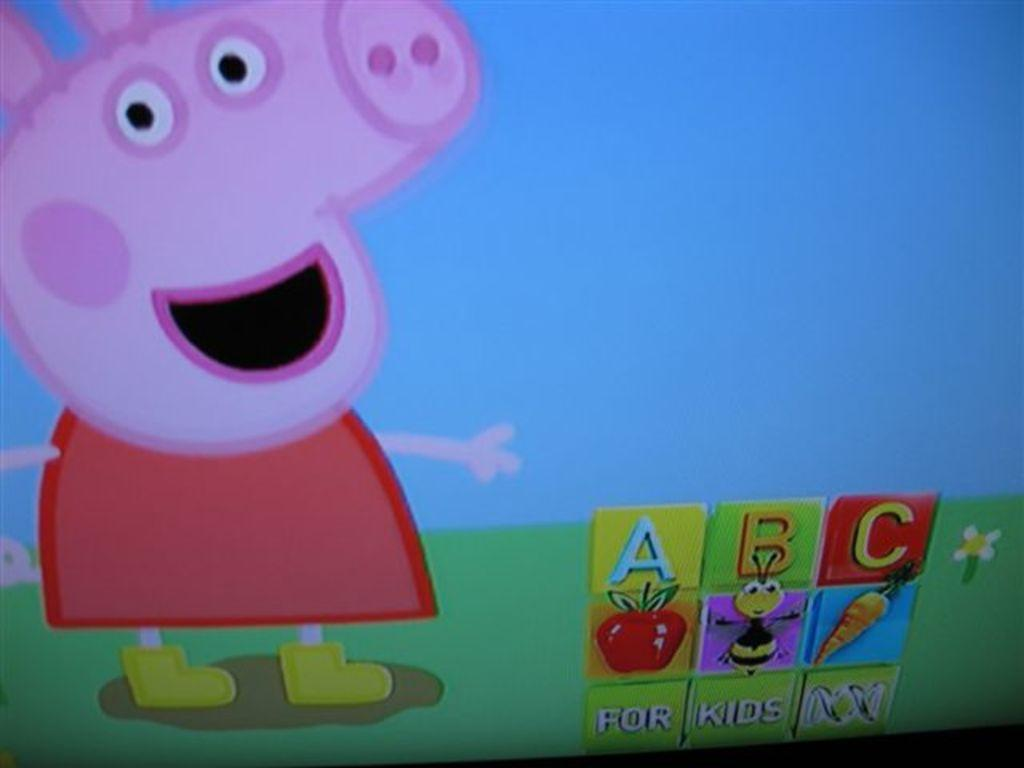What style is the image presented in? The image is a cartoon. What animal is depicted on the left side of the image? There is a picture of a pig on the left side of the image. What fruit is present in the image? There is an apple in the image. What insect is present in the image? There is a bee in the image. What vegetable is present in the image? There is a carrot in the image. Where are all these objects located in the image? All these objects are present at the bottom of the image. Is there a veil covering the pig in the image? No, there is no veil present in the image, and the pig is not covered by any veil. What angle is the bee flying at in the image? The image is a cartoon, and the bee is not shown in motion, so it is not possible to determine the angle at which it might be flying. 